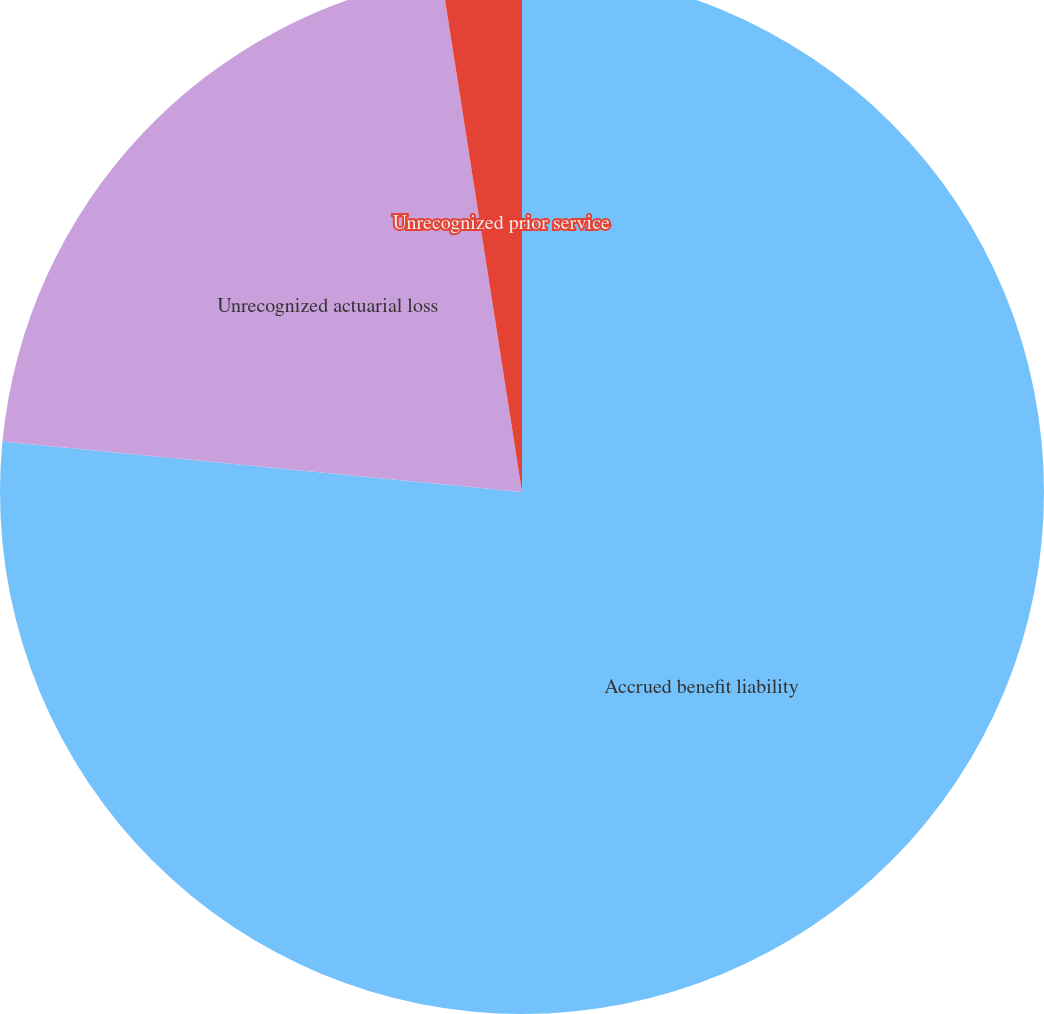<chart> <loc_0><loc_0><loc_500><loc_500><pie_chart><fcel>Accrued benefit liability<fcel>Unrecognized actuarial loss<fcel>Unrecognized prior service<nl><fcel>76.54%<fcel>20.99%<fcel>2.47%<nl></chart> 